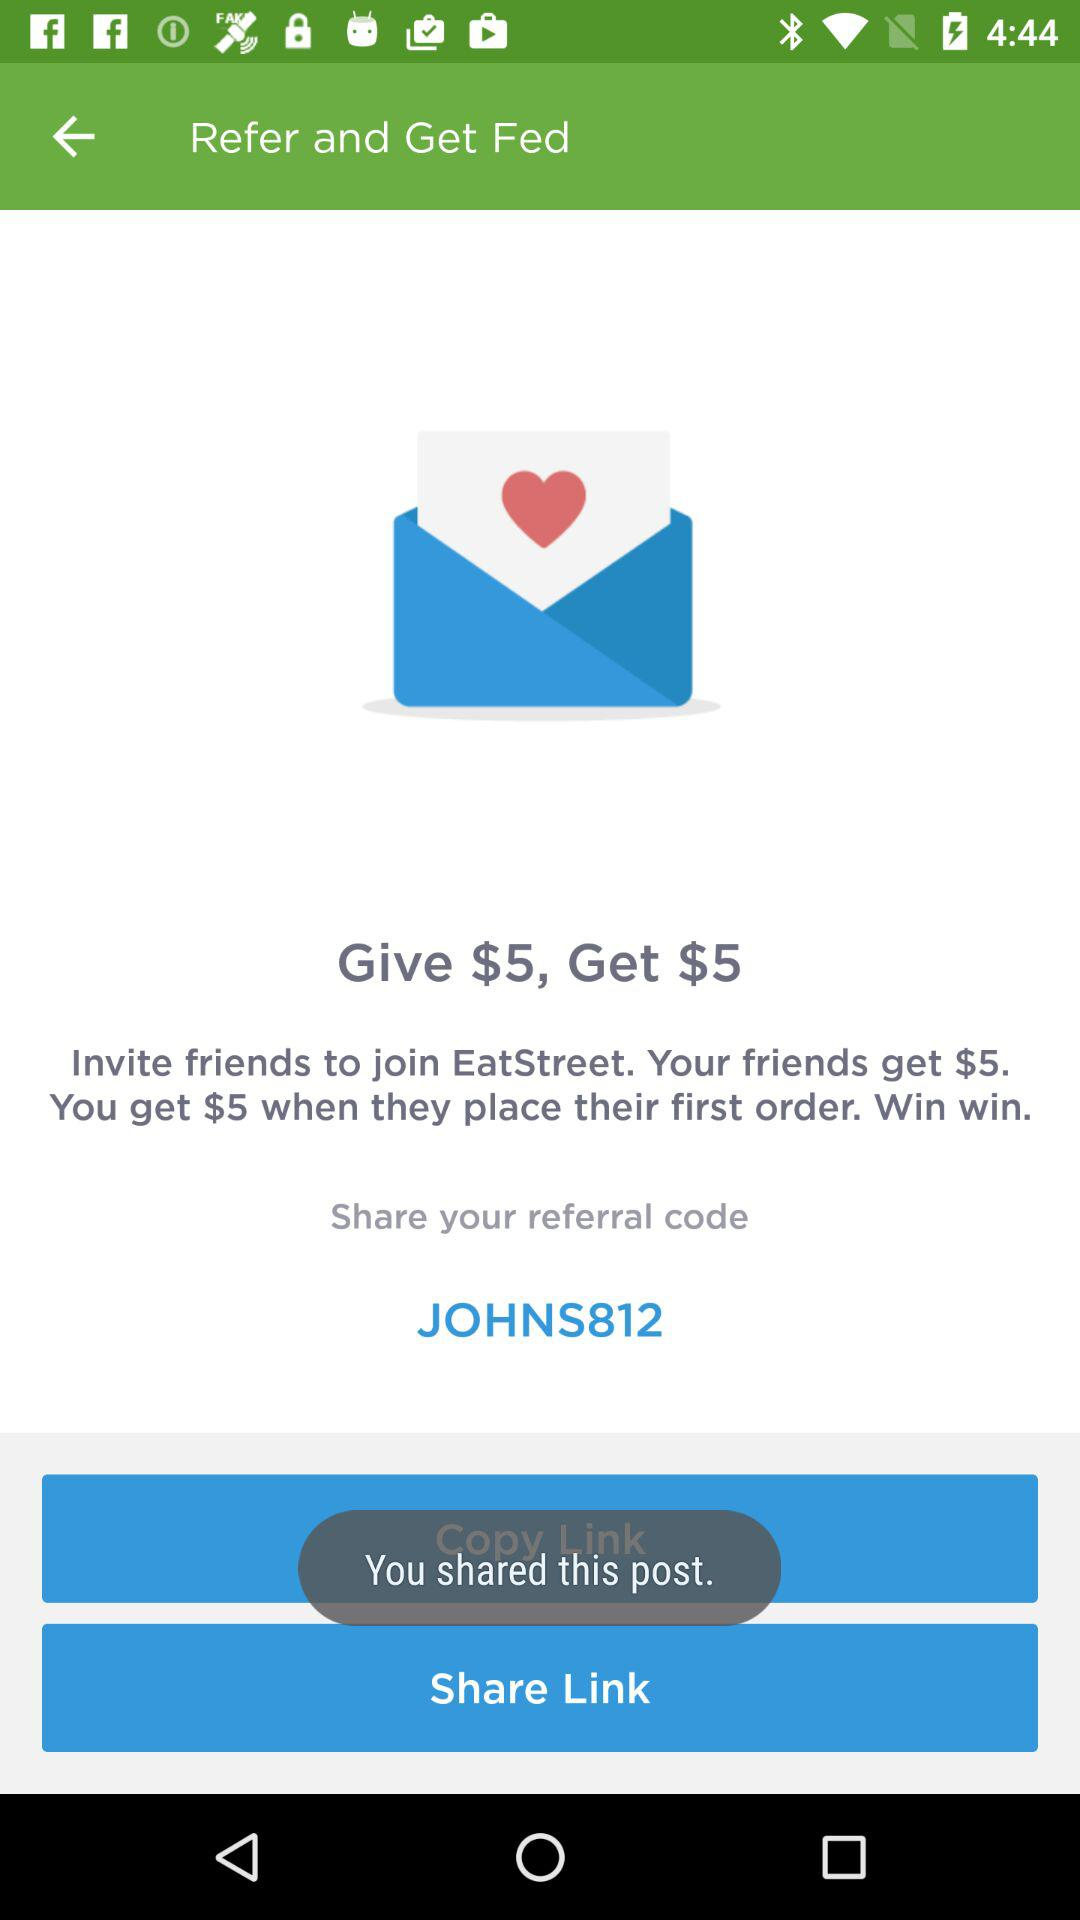What is the given referral code? The referral code is "JOHNS812". 